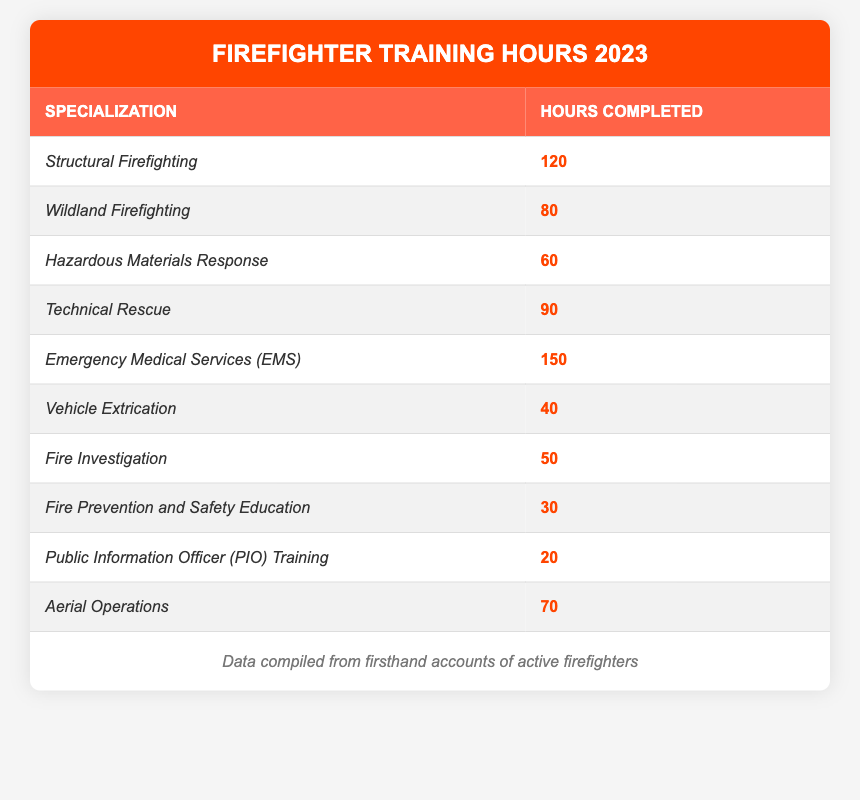What specialization had the highest training hours completed? By reviewing the table, I can see that the specialization with the highest hours is "Emergency Medical Services (EMS)" with 150 hours completed.
Answer: Emergency Medical Services (EMS) How many hours were completed in Aerial Operations? The table lists Aerial Operations with a total of 70 hours completed.
Answer: 70 What is the total number of training hours completed for Technical Rescue and Vehicle Extrication combined? I add the hours from Technical Rescue (90) and Vehicle Extrication (40) together: 90 + 40 = 130.
Answer: 130 Is the training for Fire Prevention and Safety Education more than 25 hours? Looking at the table, Fire Prevention and Safety Education has 30 hours completed, which is more than 25 hours.
Answer: Yes What is the average training hours completed across all specializations? I sum the hours: 120 + 80 + 60 + 90 + 150 + 40 + 50 + 30 + 20 + 70 = 690. There are 10 specializations, so the average is 690 / 10 = 69.
Answer: 69 Which specialization had the least training hours completed? From the table, the specialization with the least hours is "Public Information Officer (PIO) Training" with just 20 hours completed.
Answer: Public Information Officer (PIO) Training What is the difference in training hours between Structural Firefighting and Hazardous Materials Response? I find the hours for Structural Firefighting (120) and Hazardous Materials Response (60), then calculate the difference: 120 - 60 = 60.
Answer: 60 How many specializations have completed more than 60 training hours? By reviewing the table, the specializations with more than 60 hours are Structural Firefighting, Wildland Firefighting, Technical Rescue, Emergency Medical Services (EMS), and Aerial Operations. This totals 5 specializations.
Answer: 5 What percentage of total training hours does Emergency Medical Services (EMS) represent? First, I previously calculated the total training hours as 690. Then, to find the percentage: (150 / 690) * 100 = 21.74%.
Answer: 21.74% What two specializations have a combined total of less than 100 hours? I look for two specializations that together have less than 100 hours. "Vehicle Extrication" (40) and "Public Information Officer (PIO) Training" (20) add up to 60, which is less than 100.
Answer: Vehicle Extrication and Public Information Officer (PIO) Training 